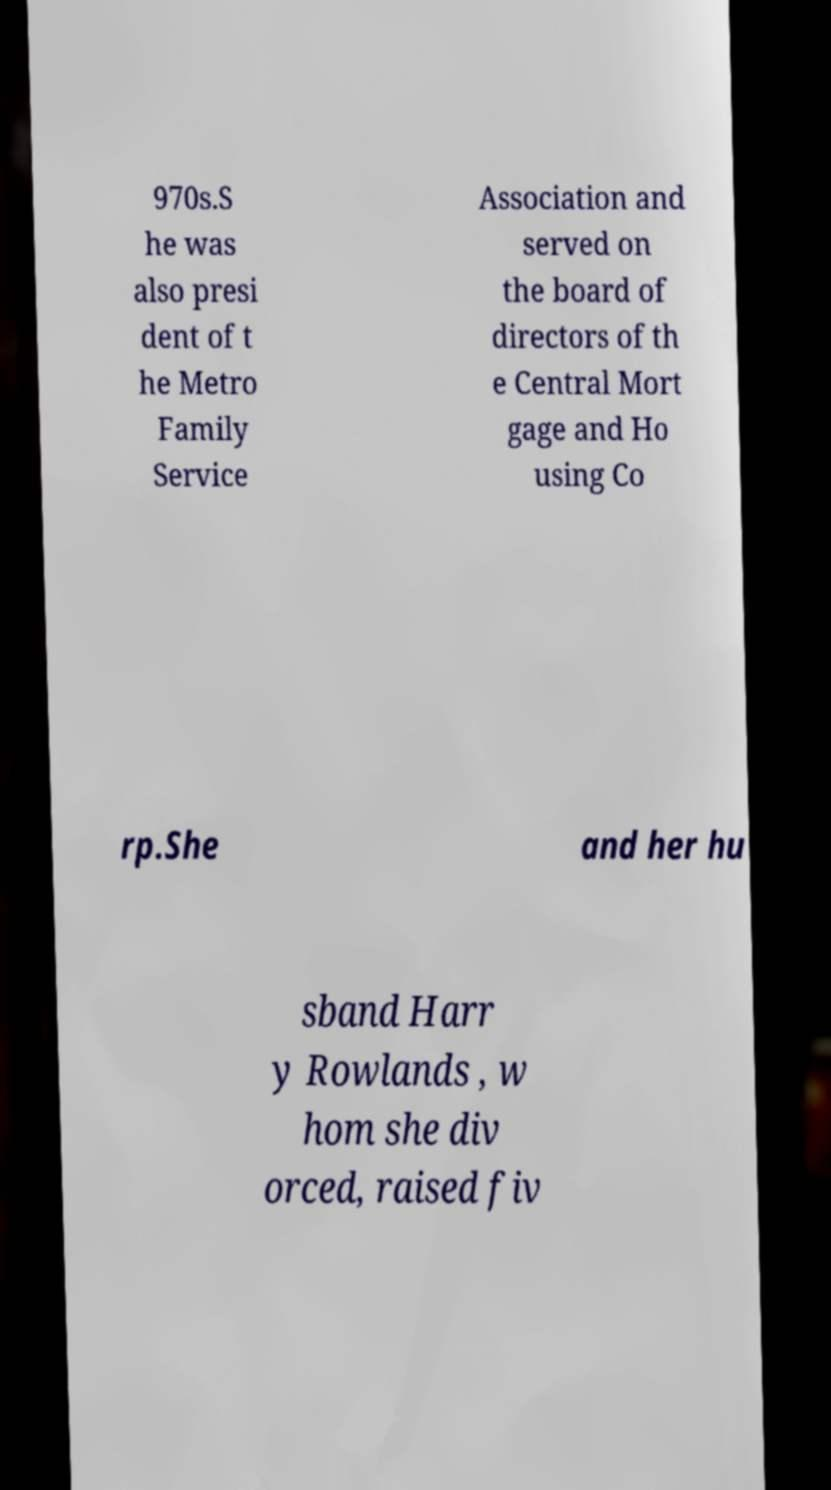Could you extract and type out the text from this image? 970s.S he was also presi dent of t he Metro Family Service Association and served on the board of directors of th e Central Mort gage and Ho using Co rp.She and her hu sband Harr y Rowlands , w hom she div orced, raised fiv 